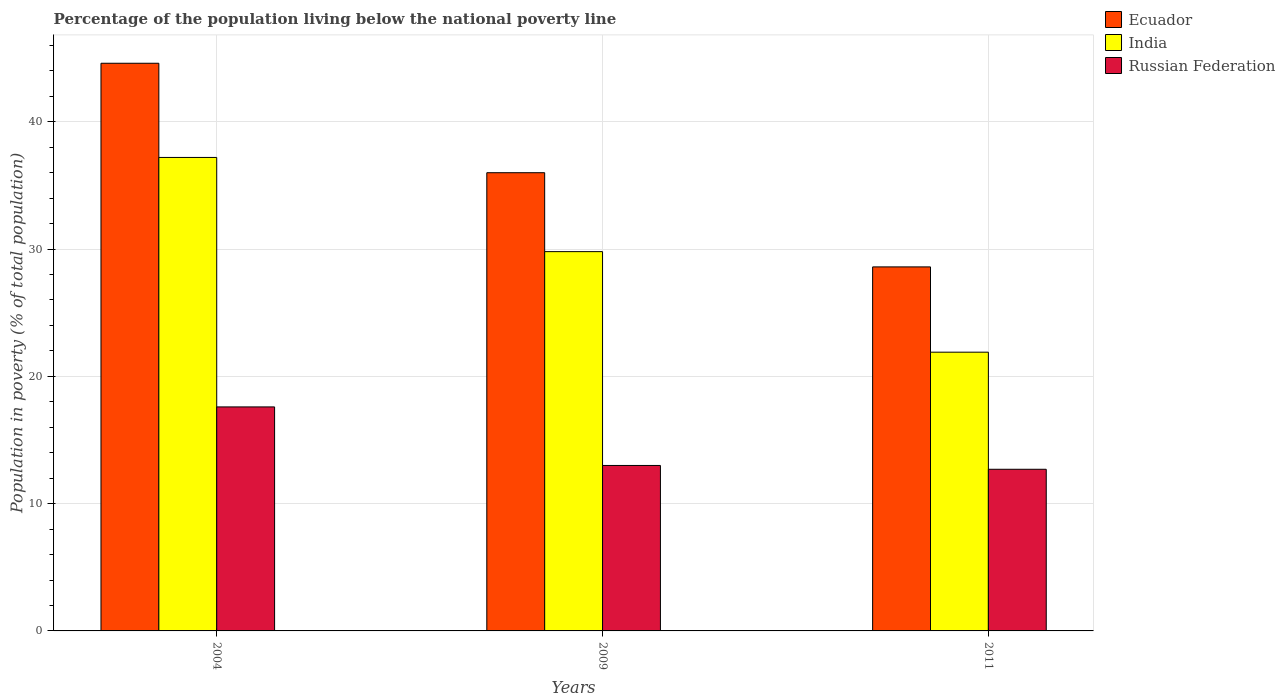How many different coloured bars are there?
Your answer should be compact. 3. How many groups of bars are there?
Your answer should be compact. 3. Are the number of bars per tick equal to the number of legend labels?
Offer a very short reply. Yes. Are the number of bars on each tick of the X-axis equal?
Your answer should be very brief. Yes. In how many cases, is the number of bars for a given year not equal to the number of legend labels?
Your response must be concise. 0. In which year was the percentage of the population living below the national poverty line in Ecuador maximum?
Your answer should be compact. 2004. In which year was the percentage of the population living below the national poverty line in India minimum?
Offer a terse response. 2011. What is the total percentage of the population living below the national poverty line in India in the graph?
Your answer should be very brief. 88.9. What is the difference between the percentage of the population living below the national poverty line in Ecuador in 2004 and that in 2011?
Your answer should be very brief. 16. What is the difference between the percentage of the population living below the national poverty line in India in 2011 and the percentage of the population living below the national poverty line in Ecuador in 2004?
Offer a very short reply. -22.7. What is the average percentage of the population living below the national poverty line in Ecuador per year?
Provide a succinct answer. 36.4. In the year 2011, what is the difference between the percentage of the population living below the national poverty line in Russian Federation and percentage of the population living below the national poverty line in Ecuador?
Offer a terse response. -15.9. What is the ratio of the percentage of the population living below the national poverty line in Ecuador in 2004 to that in 2011?
Provide a succinct answer. 1.56. Is the percentage of the population living below the national poverty line in Ecuador in 2004 less than that in 2009?
Your response must be concise. No. Is the difference between the percentage of the population living below the national poverty line in Russian Federation in 2004 and 2011 greater than the difference between the percentage of the population living below the national poverty line in Ecuador in 2004 and 2011?
Your answer should be very brief. No. What is the difference between the highest and the second highest percentage of the population living below the national poverty line in Russian Federation?
Your response must be concise. 4.6. What is the difference between the highest and the lowest percentage of the population living below the national poverty line in India?
Your answer should be very brief. 15.3. Is the sum of the percentage of the population living below the national poverty line in Ecuador in 2009 and 2011 greater than the maximum percentage of the population living below the national poverty line in India across all years?
Ensure brevity in your answer.  Yes. What does the 3rd bar from the left in 2011 represents?
Your response must be concise. Russian Federation. What does the 3rd bar from the right in 2009 represents?
Offer a terse response. Ecuador. Is it the case that in every year, the sum of the percentage of the population living below the national poverty line in India and percentage of the population living below the national poverty line in Ecuador is greater than the percentage of the population living below the national poverty line in Russian Federation?
Your answer should be very brief. Yes. How many bars are there?
Provide a succinct answer. 9. What is the title of the graph?
Provide a succinct answer. Percentage of the population living below the national poverty line. What is the label or title of the X-axis?
Your answer should be compact. Years. What is the label or title of the Y-axis?
Offer a very short reply. Population in poverty (% of total population). What is the Population in poverty (% of total population) of Ecuador in 2004?
Offer a terse response. 44.6. What is the Population in poverty (% of total population) of India in 2004?
Your answer should be compact. 37.2. What is the Population in poverty (% of total population) of Ecuador in 2009?
Your response must be concise. 36. What is the Population in poverty (% of total population) in India in 2009?
Offer a very short reply. 29.8. What is the Population in poverty (% of total population) in Ecuador in 2011?
Make the answer very short. 28.6. What is the Population in poverty (% of total population) of India in 2011?
Provide a succinct answer. 21.9. Across all years, what is the maximum Population in poverty (% of total population) in Ecuador?
Your response must be concise. 44.6. Across all years, what is the maximum Population in poverty (% of total population) in India?
Provide a succinct answer. 37.2. Across all years, what is the minimum Population in poverty (% of total population) in Ecuador?
Keep it short and to the point. 28.6. Across all years, what is the minimum Population in poverty (% of total population) of India?
Keep it short and to the point. 21.9. What is the total Population in poverty (% of total population) of Ecuador in the graph?
Provide a succinct answer. 109.2. What is the total Population in poverty (% of total population) of India in the graph?
Offer a terse response. 88.9. What is the total Population in poverty (% of total population) of Russian Federation in the graph?
Ensure brevity in your answer.  43.3. What is the difference between the Population in poverty (% of total population) of India in 2004 and that in 2009?
Give a very brief answer. 7.4. What is the difference between the Population in poverty (% of total population) in Russian Federation in 2004 and that in 2009?
Keep it short and to the point. 4.6. What is the difference between the Population in poverty (% of total population) of Ecuador in 2004 and that in 2011?
Provide a short and direct response. 16. What is the difference between the Population in poverty (% of total population) of Ecuador in 2004 and the Population in poverty (% of total population) of India in 2009?
Your answer should be compact. 14.8. What is the difference between the Population in poverty (% of total population) of Ecuador in 2004 and the Population in poverty (% of total population) of Russian Federation in 2009?
Keep it short and to the point. 31.6. What is the difference between the Population in poverty (% of total population) in India in 2004 and the Population in poverty (% of total population) in Russian Federation in 2009?
Provide a succinct answer. 24.2. What is the difference between the Population in poverty (% of total population) of Ecuador in 2004 and the Population in poverty (% of total population) of India in 2011?
Offer a terse response. 22.7. What is the difference between the Population in poverty (% of total population) of Ecuador in 2004 and the Population in poverty (% of total population) of Russian Federation in 2011?
Offer a very short reply. 31.9. What is the difference between the Population in poverty (% of total population) in Ecuador in 2009 and the Population in poverty (% of total population) in Russian Federation in 2011?
Your answer should be very brief. 23.3. What is the difference between the Population in poverty (% of total population) in India in 2009 and the Population in poverty (% of total population) in Russian Federation in 2011?
Your answer should be compact. 17.1. What is the average Population in poverty (% of total population) of Ecuador per year?
Offer a terse response. 36.4. What is the average Population in poverty (% of total population) of India per year?
Provide a succinct answer. 29.63. What is the average Population in poverty (% of total population) in Russian Federation per year?
Your answer should be compact. 14.43. In the year 2004, what is the difference between the Population in poverty (% of total population) in Ecuador and Population in poverty (% of total population) in India?
Make the answer very short. 7.4. In the year 2004, what is the difference between the Population in poverty (% of total population) of India and Population in poverty (% of total population) of Russian Federation?
Your response must be concise. 19.6. In the year 2011, what is the difference between the Population in poverty (% of total population) of Ecuador and Population in poverty (% of total population) of India?
Provide a succinct answer. 6.7. In the year 2011, what is the difference between the Population in poverty (% of total population) in India and Population in poverty (% of total population) in Russian Federation?
Provide a succinct answer. 9.2. What is the ratio of the Population in poverty (% of total population) of Ecuador in 2004 to that in 2009?
Offer a very short reply. 1.24. What is the ratio of the Population in poverty (% of total population) in India in 2004 to that in 2009?
Your answer should be compact. 1.25. What is the ratio of the Population in poverty (% of total population) of Russian Federation in 2004 to that in 2009?
Offer a terse response. 1.35. What is the ratio of the Population in poverty (% of total population) of Ecuador in 2004 to that in 2011?
Keep it short and to the point. 1.56. What is the ratio of the Population in poverty (% of total population) in India in 2004 to that in 2011?
Your answer should be compact. 1.7. What is the ratio of the Population in poverty (% of total population) in Russian Federation in 2004 to that in 2011?
Offer a terse response. 1.39. What is the ratio of the Population in poverty (% of total population) of Ecuador in 2009 to that in 2011?
Your response must be concise. 1.26. What is the ratio of the Population in poverty (% of total population) of India in 2009 to that in 2011?
Your answer should be very brief. 1.36. What is the ratio of the Population in poverty (% of total population) of Russian Federation in 2009 to that in 2011?
Make the answer very short. 1.02. What is the difference between the highest and the second highest Population in poverty (% of total population) of Ecuador?
Keep it short and to the point. 8.6. What is the difference between the highest and the second highest Population in poverty (% of total population) in India?
Your answer should be very brief. 7.4. What is the difference between the highest and the lowest Population in poverty (% of total population) of Ecuador?
Offer a terse response. 16. What is the difference between the highest and the lowest Population in poverty (% of total population) of Russian Federation?
Keep it short and to the point. 4.9. 